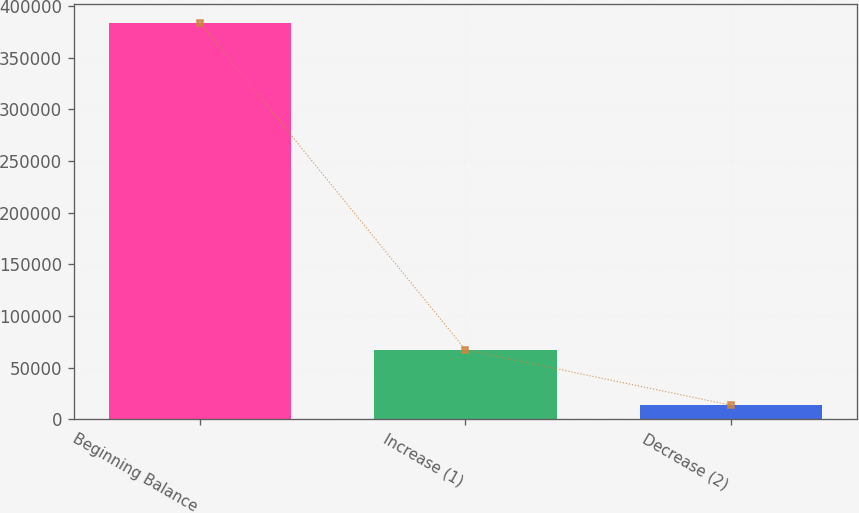Convert chart. <chart><loc_0><loc_0><loc_500><loc_500><bar_chart><fcel>Beginning Balance<fcel>Increase (1)<fcel>Decrease (2)<nl><fcel>383221<fcel>67333<fcel>13687<nl></chart> 